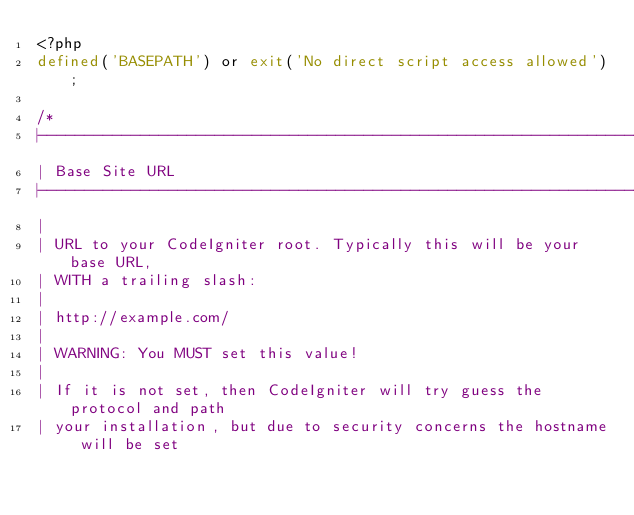<code> <loc_0><loc_0><loc_500><loc_500><_PHP_><?php
defined('BASEPATH') or exit('No direct script access allowed');

/*
|--------------------------------------------------------------------------
| Base Site URL
|--------------------------------------------------------------------------
|
| URL to your CodeIgniter root. Typically this will be your base URL,
| WITH a trailing slash:
|
|	http://example.com/
|
| WARNING: You MUST set this value!
|
| If it is not set, then CodeIgniter will try guess the protocol and path
| your installation, but due to security concerns the hostname will be set</code> 